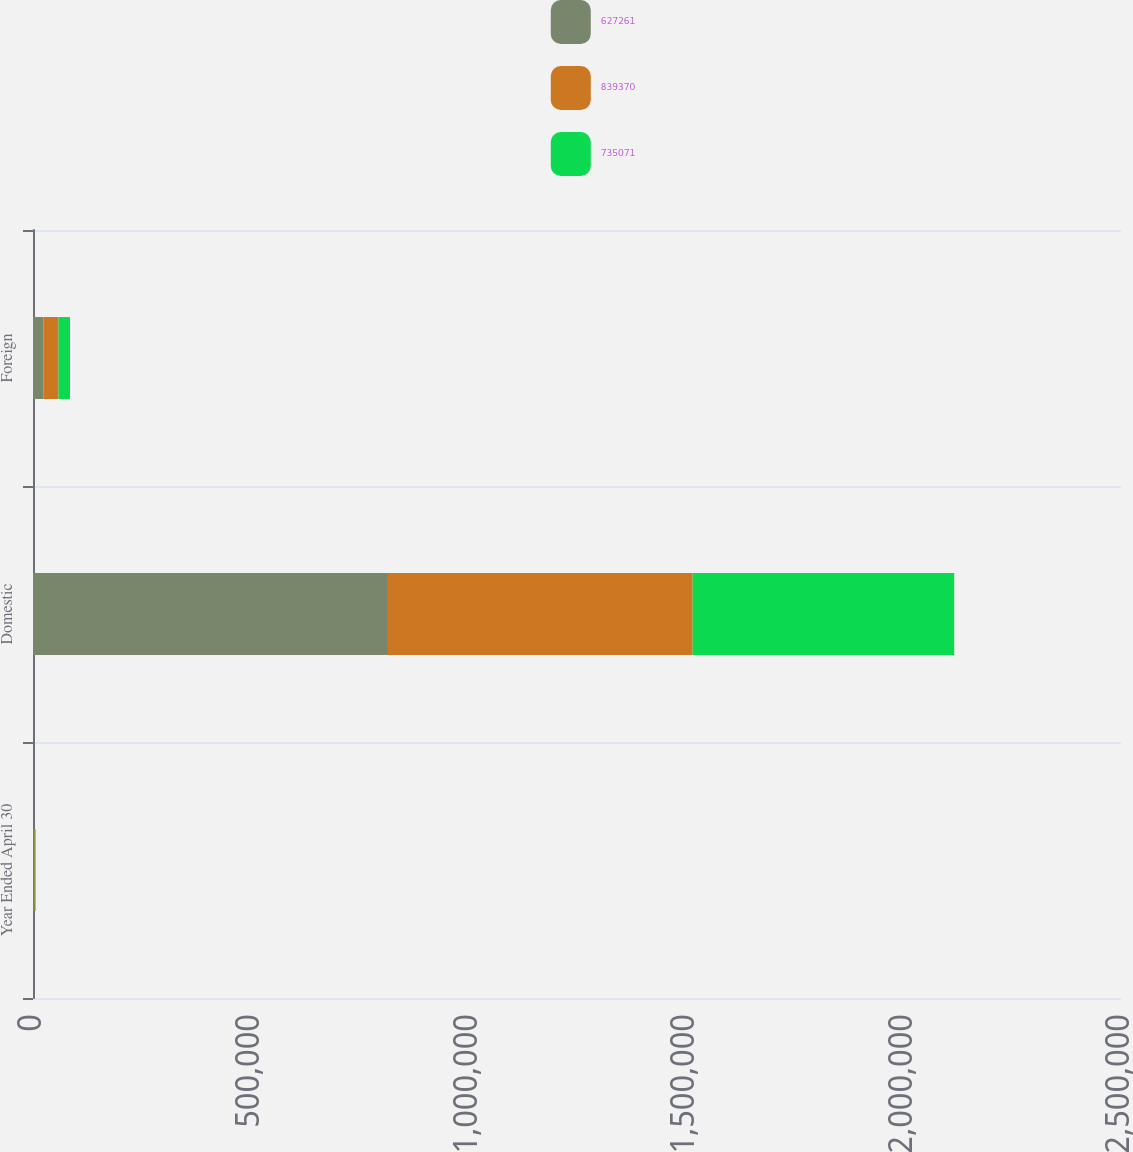Convert chart. <chart><loc_0><loc_0><loc_500><loc_500><stacked_bar_chart><ecel><fcel>Year Ended April 30<fcel>Domestic<fcel>Foreign<nl><fcel>627261<fcel>2009<fcel>815614<fcel>23756<nl><fcel>839370<fcel>2008<fcel>700162<fcel>34909<nl><fcel>735071<fcel>2007<fcel>600964<fcel>26297<nl></chart> 